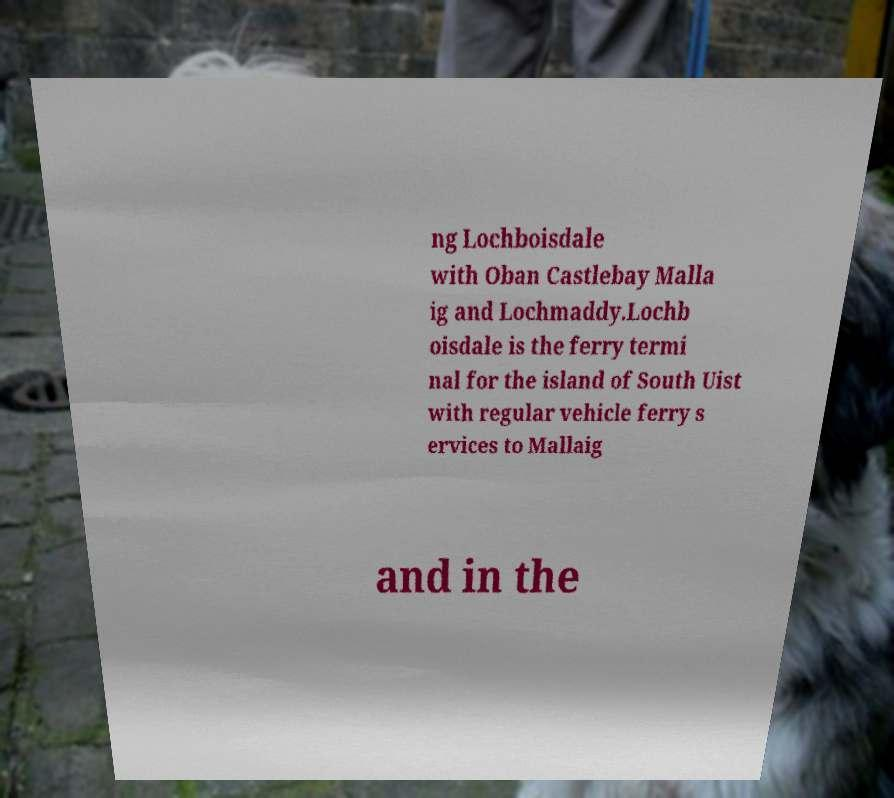What messages or text are displayed in this image? I need them in a readable, typed format. ng Lochboisdale with Oban Castlebay Malla ig and Lochmaddy.Lochb oisdale is the ferry termi nal for the island of South Uist with regular vehicle ferry s ervices to Mallaig and in the 